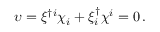<formula> <loc_0><loc_0><loc_500><loc_500>\upsilon = \xi ^ { \dagger i } \chi _ { i } + \xi _ { i } ^ { \dagger } \chi ^ { i } = 0 \, .</formula> 